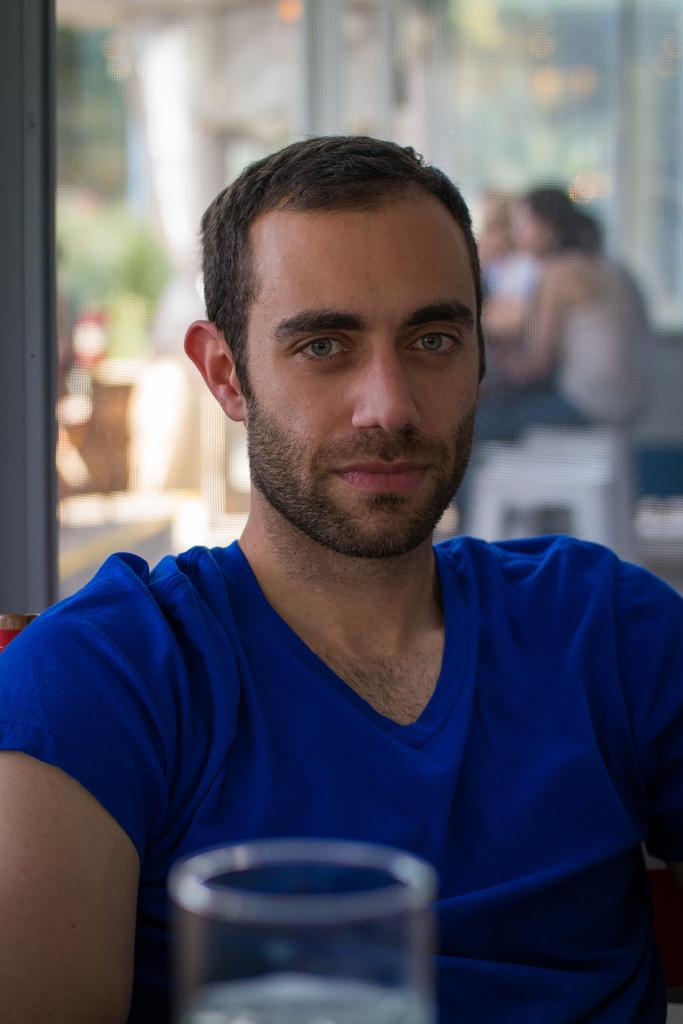What can be seen in the image? There is a person in the image. What is the person wearing? The person is wearing a T-shirt. What else is visible in the image? There is a glass with some liquid in the image. Can you describe the background of the image? The background of the image is blurred. How many jellyfish are swimming in the glass with liquid in the image? There are no jellyfish present in the image; it only contains a glass with some liquid. 